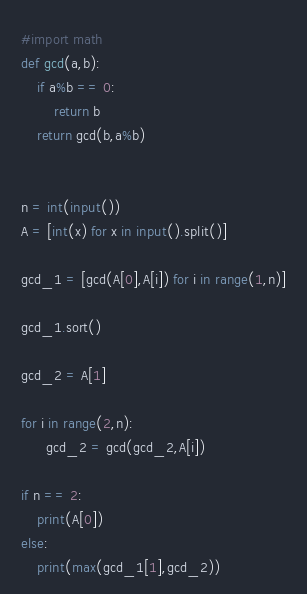<code> <loc_0><loc_0><loc_500><loc_500><_Python_>#import math
def gcd(a,b):
    if a%b == 0:
        return b
    return gcd(b,a%b)


n = int(input())
A = [int(x) for x in input().split()]

gcd_1 = [gcd(A[0],A[i]) for i in range(1,n)]

gcd_1.sort()

gcd_2 = A[1]

for i in range(2,n):
      gcd_2 = gcd(gcd_2,A[i])

if n == 2:
    print(A[0])
else:
    print(max(gcd_1[1],gcd_2))
</code> 